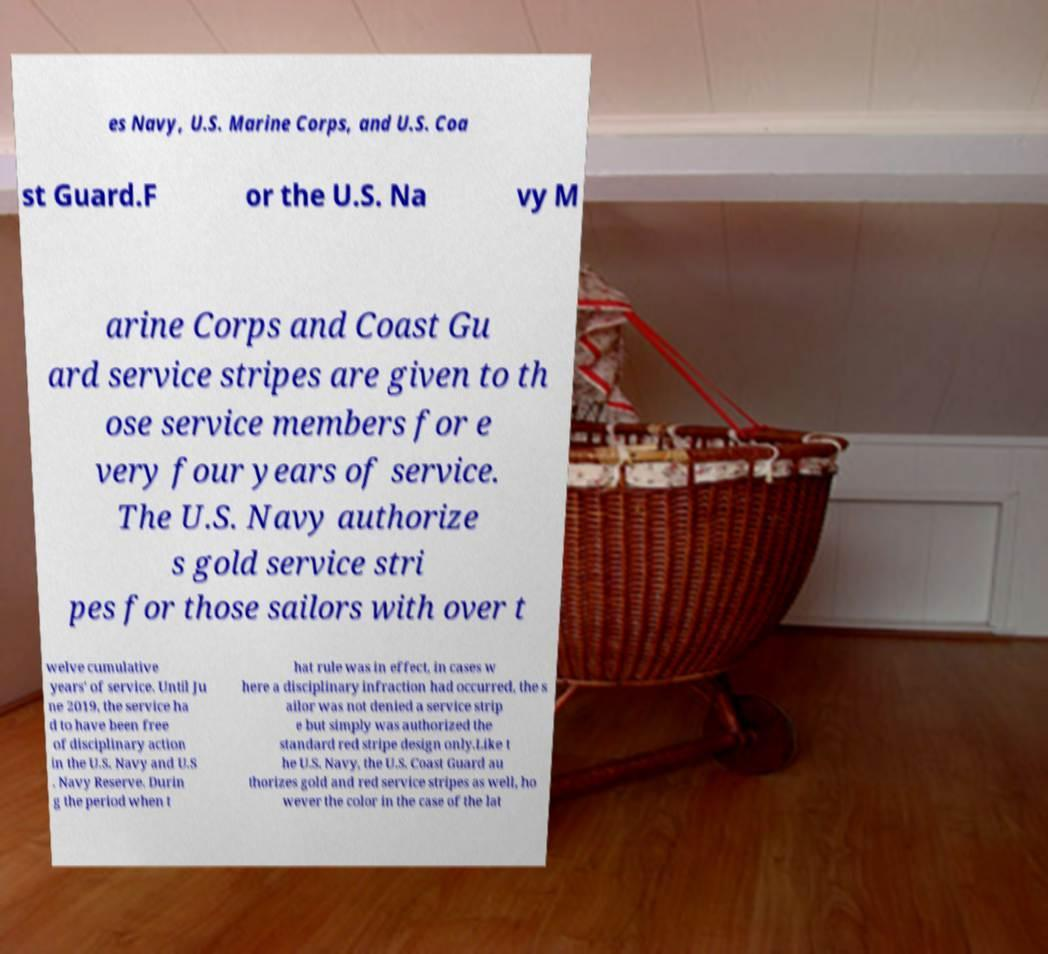There's text embedded in this image that I need extracted. Can you transcribe it verbatim? es Navy, U.S. Marine Corps, and U.S. Coa st Guard.F or the U.S. Na vy M arine Corps and Coast Gu ard service stripes are given to th ose service members for e very four years of service. The U.S. Navy authorize s gold service stri pes for those sailors with over t welve cumulative years' of service. Until Ju ne 2019, the service ha d to have been free of disciplinary action in the U.S. Navy and U.S . Navy Reserve. Durin g the period when t hat rule was in effect, in cases w here a disciplinary infraction had occurred, the s ailor was not denied a service strip e but simply was authorized the standard red stripe design only.Like t he U.S. Navy, the U.S. Coast Guard au thorizes gold and red service stripes as well, ho wever the color in the case of the lat 